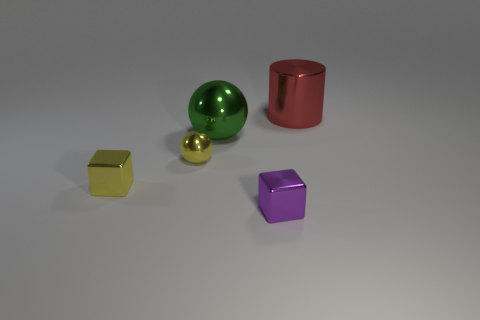What is the shape of the other big thing that is made of the same material as the red thing?
Offer a very short reply. Sphere. What number of metal things are either yellow things or big spheres?
Ensure brevity in your answer.  3. There is a tiny metal cube that is left of the block right of the green shiny object; what number of large red cylinders are on the left side of it?
Offer a terse response. 0. Do the thing that is to the right of the purple metallic object and the shiny ball left of the large metal sphere have the same size?
Provide a short and direct response. No. What material is the other tiny object that is the same shape as the purple thing?
Keep it short and to the point. Metal. What number of large things are yellow balls or red rubber cylinders?
Offer a terse response. 0. What material is the big green ball?
Make the answer very short. Metal. There is a thing that is both right of the big green sphere and behind the small yellow shiny ball; what is it made of?
Provide a succinct answer. Metal. Is the color of the big ball the same as the metallic block that is to the left of the tiny purple metallic cube?
Make the answer very short. No. There is a yellow sphere that is the same size as the purple block; what is its material?
Offer a very short reply. Metal. 